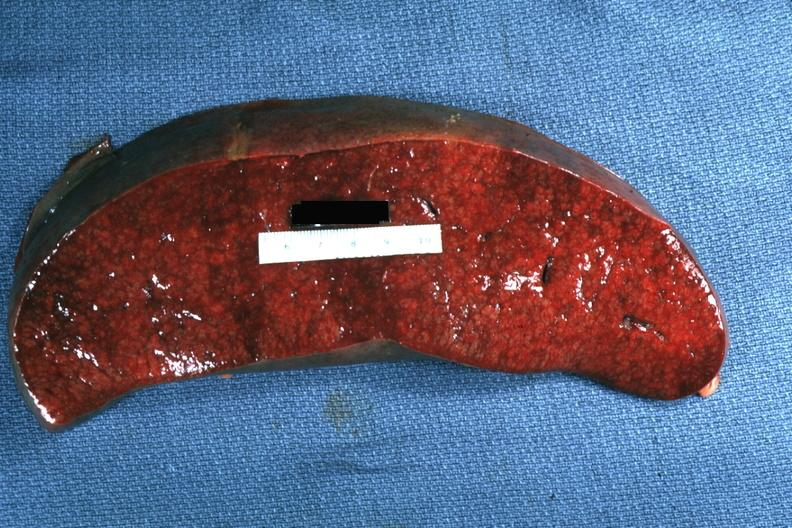where is this part in?
Answer the question using a single word or phrase. Spleen 